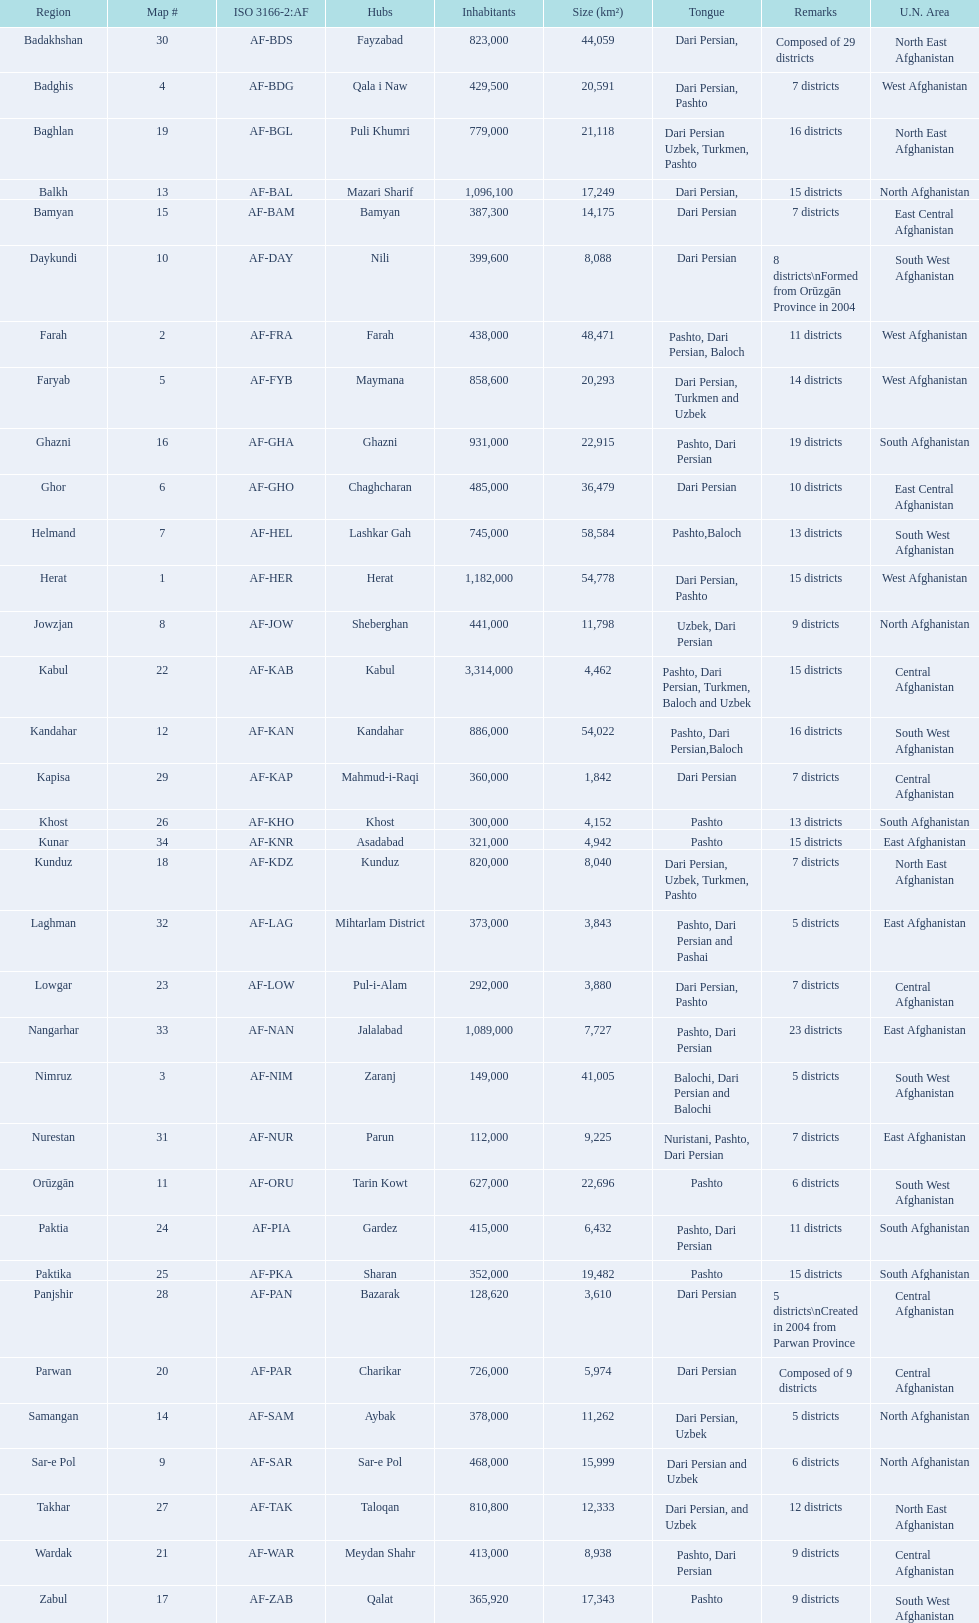How many provinces have the same number of districts as kabul? 4. 